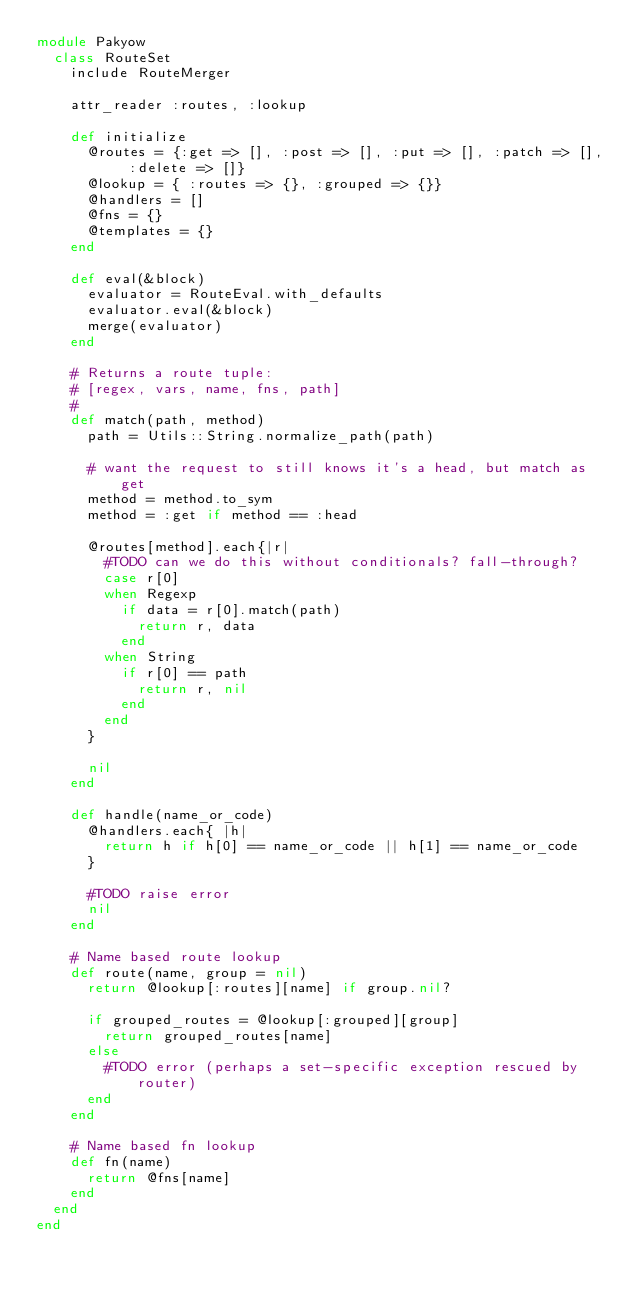Convert code to text. <code><loc_0><loc_0><loc_500><loc_500><_Ruby_>module Pakyow
  class RouteSet
    include RouteMerger

    attr_reader :routes, :lookup

    def initialize
      @routes = {:get => [], :post => [], :put => [], :patch => [], :delete => []}
      @lookup = { :routes => {}, :grouped => {}}
      @handlers = []
      @fns = {}
      @templates = {}
    end

    def eval(&block)
      evaluator = RouteEval.with_defaults
      evaluator.eval(&block)
      merge(evaluator)
    end

    # Returns a route tuple:
    # [regex, vars, name, fns, path]
    #
    def match(path, method)
      path = Utils::String.normalize_path(path)

      # want the request to still knows it's a head, but match as get
      method = method.to_sym
      method = :get if method == :head

      @routes[method].each{|r|
        #TODO can we do this without conditionals? fall-through?
        case r[0]
        when Regexp
          if data = r[0].match(path)
            return r, data
          end
        when String
          if r[0] == path
            return r, nil
          end
        end
      }

      nil
    end

    def handle(name_or_code)
      @handlers.each{ |h|
        return h if h[0] == name_or_code || h[1] == name_or_code
      }

      #TODO raise error
      nil
    end

    # Name based route lookup
    def route(name, group = nil)
      return @lookup[:routes][name] if group.nil?

      if grouped_routes = @lookup[:grouped][group]
        return grouped_routes[name]
      else
        #TODO error (perhaps a set-specific exception rescued by router)
      end
    end

    # Name based fn lookup
    def fn(name)
      return @fns[name]
    end
  end
end

</code> 